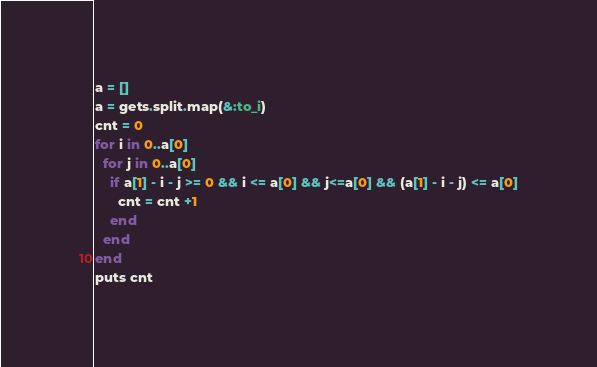Convert code to text. <code><loc_0><loc_0><loc_500><loc_500><_Ruby_>a = []
a = gets.split.map(&:to_i)
cnt = 0
for i in 0..a[0]
  for j in 0..a[0]
    if a[1] - i - j >= 0 && i <= a[0] && j<=a[0] && (a[1] - i - j) <= a[0]
      cnt = cnt +1
    end
  end
end
puts cnt</code> 